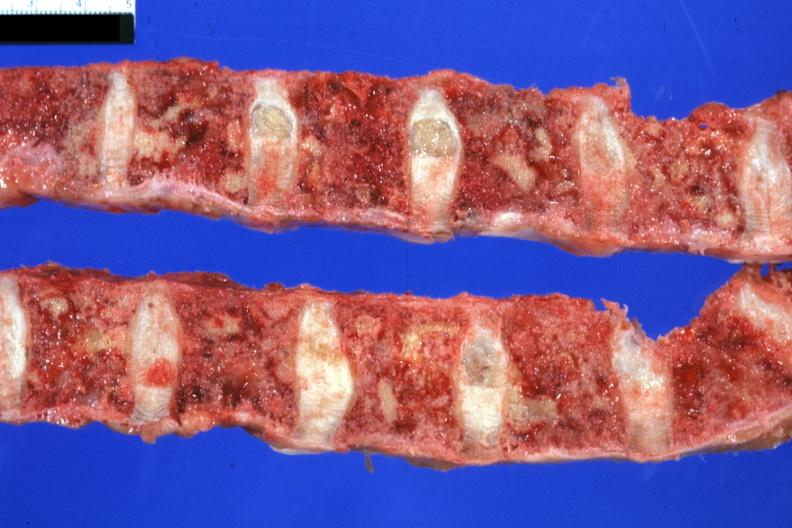what is present?
Answer the question using a single word or phrase. Joints 